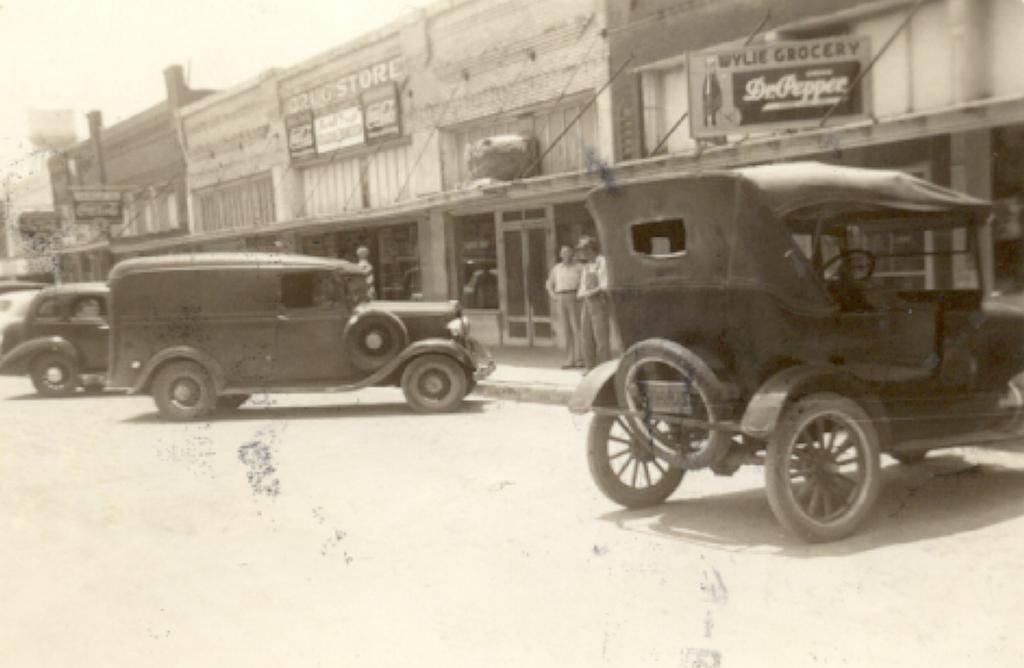In one or two sentences, can you explain what this image depicts? This is a black and white picture. Here we can see vehicles, buildings, boards, and two persons. In the background there is sky. 